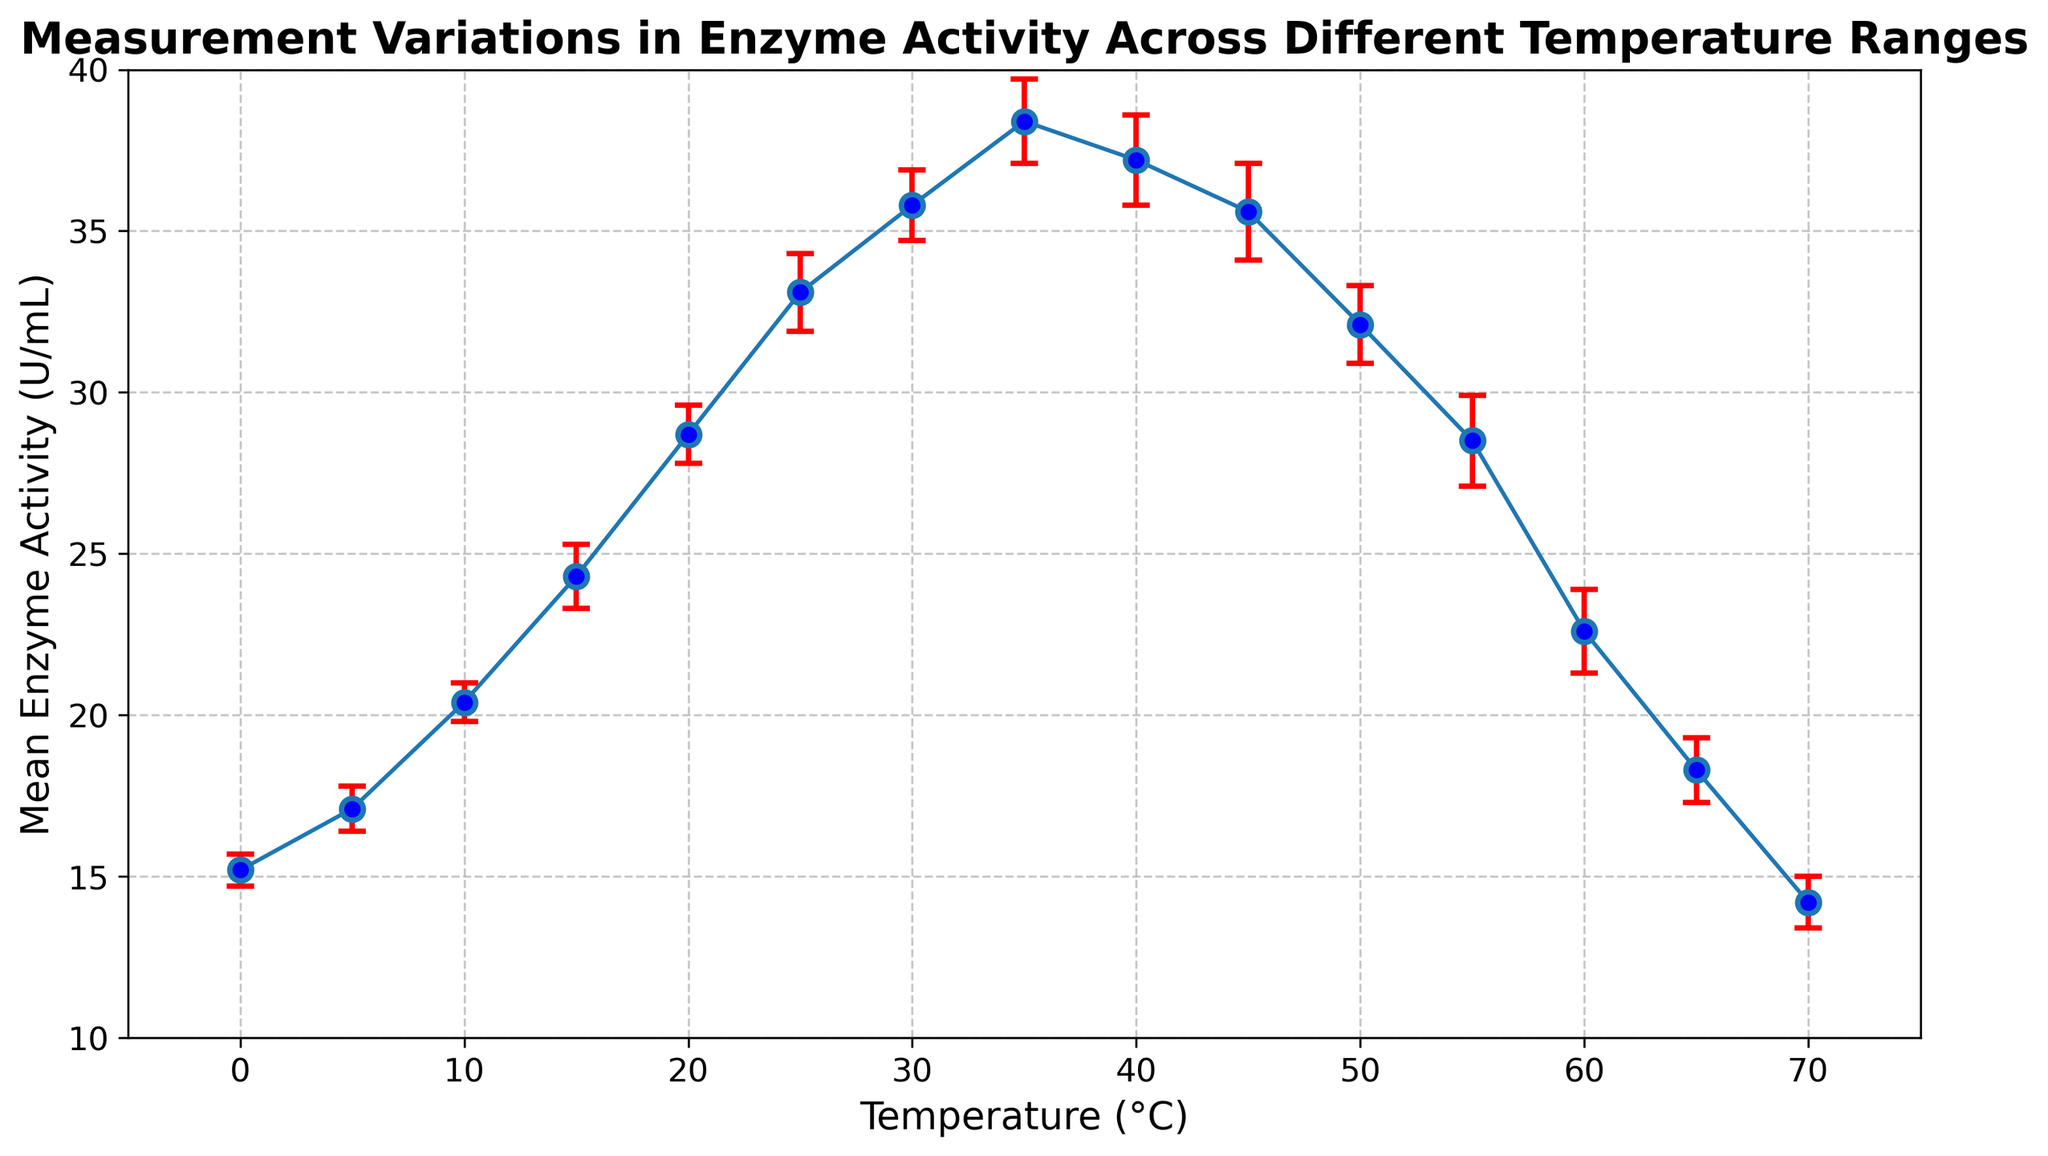What is the highest mean enzyme activity recorded and at what temperature was this observed? The highest mean enzyme activity observed must be found from the plot by identifying the peak value on the y-axis and corresponding temperature on the x-axis. It is around 38.4 U/mL at 35°C.
Answer: 38.4 U/mL at 35°C Is the mean enzyme activity at 40°C greater than at 45°C? To answer this question, note the y-axis values for temperatures 40°C and 45°C and compare them. The mean enzyme activity at 40°C (37.2 U/mL) is greater than at 45°C (35.6 U/mL).
Answer: Yes Calculate the range of mean enzyme activity observed between 10°C and 30°C. First, identify the highest and lowest mean enzyme activity values between 10°C and 30°C from the plot: the highest is 35.8 U/mL at 30°C and the lowest is 20.4 U/mL at 10°C. Subtract the lowest value from the highest to get the range: 35.8 - 20.4 = 15.4 U/mL.
Answer: 15.4 U/mL How does the mean enzyme activity change between 0°C and 25°C visually? To answer this question, observe the trend in mean enzyme activity from 0°C to 25°C. The plot shows an upward trend where the mean enzyme activity steadily increases from 15.2 U/mL at 0°C to 33.1 U/mL at 25°C.
Answer: It increases Compare the standard deviations at 20°C and 55°C. Which is larger? Look for the error bars at 20°C and 55°C on the plot. The standard deviation at 20°C is 0.9 U/mL and at 55°C, it is 1.4 U/mL. Hence, the standard deviation at 55°C is larger.
Answer: 55°C What temperature range shows a decrease in mean enzyme activity? Identify the temperature range where the trend in mean enzyme activity moves downward. The plot shows a decline in mean enzyme activity from 40°C (37.2 U/mL) to 70°C (14.2 U/mL). So, the temperature range of interest is from 40°C to 70°C.
Answer: 40°C to 70°C What is the difference in mean enzyme activity between 30°C and 50°C? Find the mean enzyme activity at 30°C and 50°C from the plot: 35.8 U/mL at 30°C and 32.1 U/mL at 50°C. Subtract the mean enzyme activity at 50°C from that at 30°C: 35.8 - 32.1 = 3.7 U/mL.
Answer: 3.7 U/mL Is there any temperature at which the mean enzyme activity and the standard deviation add up to exactly 30 U/mL? To answer this, add the mean enzyme activity and the standard deviation values for each temperature and see if the sum is exactly 30 U/mL. Checking the plot, at 0°C: 15.2+0.5 = 15.7, at 5°C: 17.1+0.7 = 17.8, ..., at 15°C: 24.3+1.0 = 25.3 ... and so on. No temperature matches this condition.
Answer: No Which temperature shows the smallest standard deviation and what is its value? Identify the shortest error bar on the plot. The temperature with the smallest standard deviation is 0°C with a standard deviation of 0.5 U/mL.
Answer: 0°C (0.5 U/mL) 